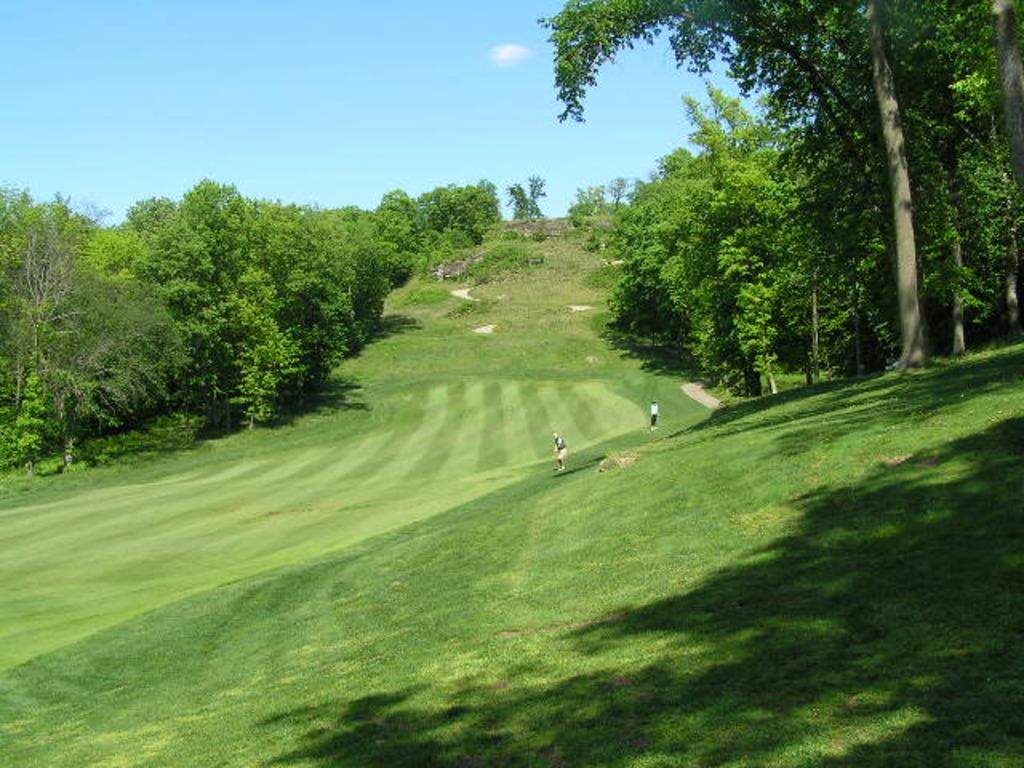How many people are in the image? There are two people standing in the image. What are the people wearing? The people are wearing clothes. What type of natural environment is visible in the image? There is grass, trees, and a path visible in the image. What is the color of the sky in the image? The sky is pale blue in the image. Can you tell me how many pages are in the book that the rat is holding in the image? There is no rat or book present in the image; it features two people standing in a natural environment. 